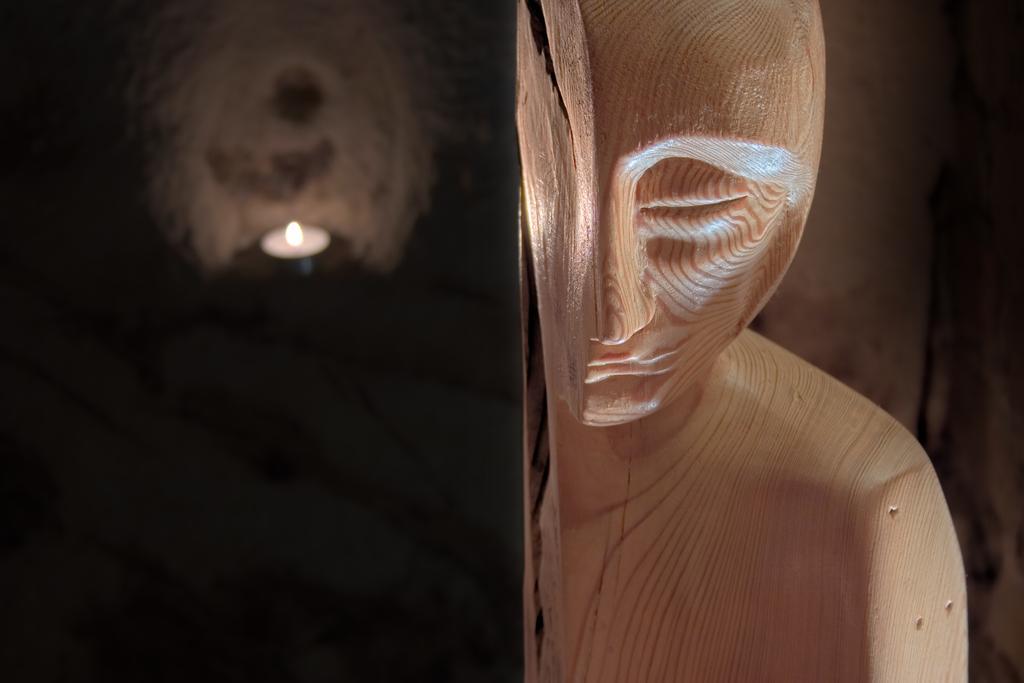Describe this image in one or two sentences. In this image on the right side there is a wooden statue. On the left side the background is blurry. 